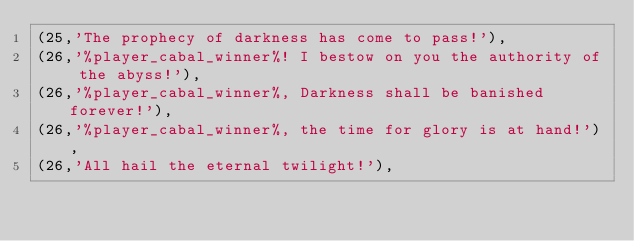Convert code to text. <code><loc_0><loc_0><loc_500><loc_500><_SQL_>(25,'The prophecy of darkness has come to pass!'),
(26,'%player_cabal_winner%! I bestow on you the authority of the abyss!'),
(26,'%player_cabal_winner%, Darkness shall be banished forever!'),
(26,'%player_cabal_winner%, the time for glory is at hand!'),
(26,'All hail the eternal twilight!'),</code> 